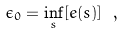Convert formula to latex. <formula><loc_0><loc_0><loc_500><loc_500>\epsilon _ { 0 } = \inf _ { s } [ e ( s ) ] \ ,</formula> 